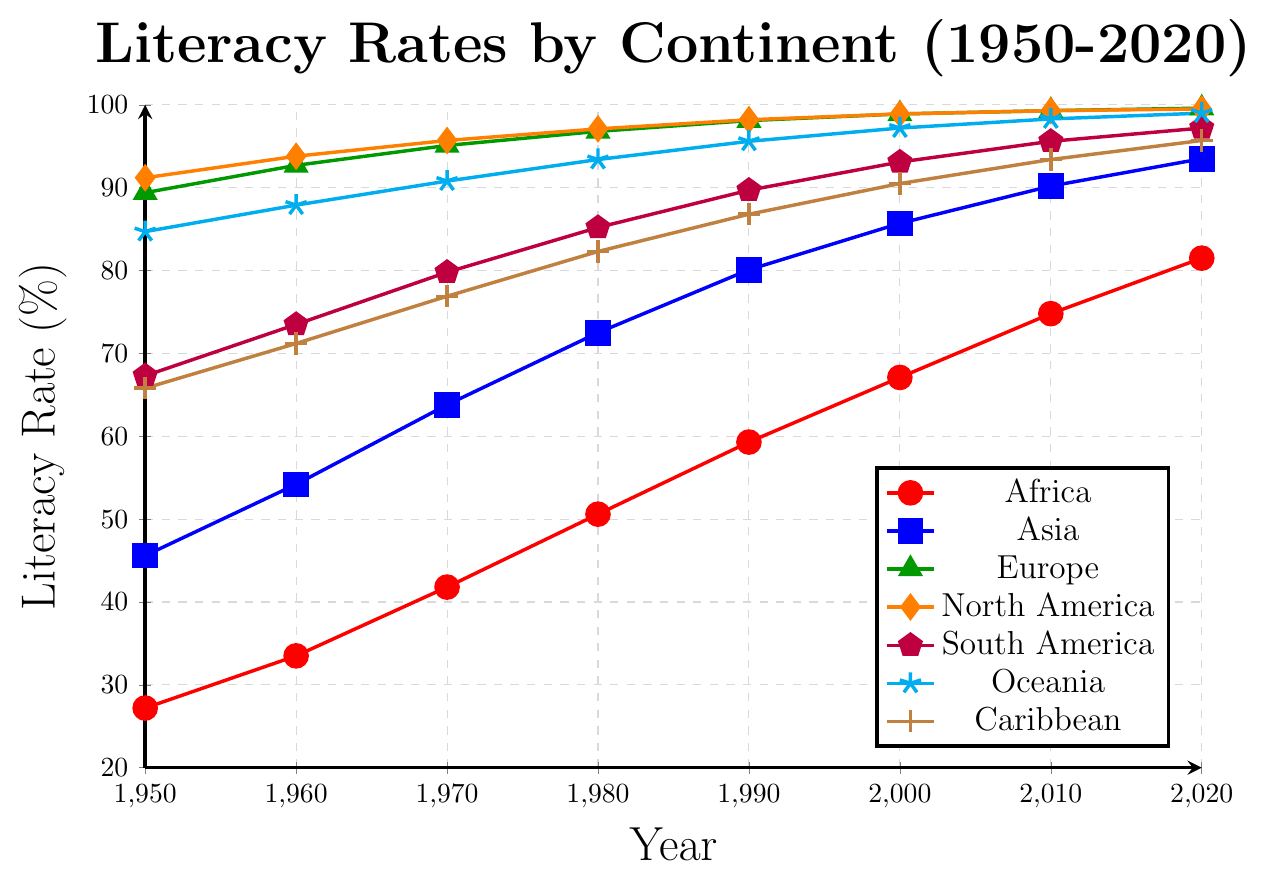Which continent had the lowest literacy rate in 1950? By visually inspecting the figure, the red line representing Africa starts at the lowest point in 1950 compared to the other continents.
Answer: Africa How did the literacy rate in Africa change from 1950 to 2020? Referring to the path of the red line, the literacy rate in Africa increased from 27.2% in 1950 to 81.5% in 2020.
Answer: It increased from 27.2% to 81.5% Which continent had the highest literacy rate in the year 2000? By observing the figure, Europe, represented by the green line, had the highest literacy rate in 2000 at 98.9%.
Answer: Europe Compare the literacy rates of South America and Asia in 1980. Which was higher and by how much? In 1980, South America's literacy rate (purple line) was 85.2%, and Asia's literacy rate (blue line) was 72.5%. The difference is 85.2% - 72.5% = 12.7%.
Answer: South America by 12.7% How many continents had at least a 90% literacy rate by 2020? From the figure, the continents with literacy rates of 90% or higher in 2020 are Europe, North America, South America, Asia, Oceania, and the Caribbean. That's 6 continents.
Answer: Six continents What is the average literacy rate of Oceania from 1950 to 2020? The literacy rates of Oceania (cyan line) for the years are 84.7, 87.9, 90.8, 93.4, 95.6, 97.2, 98.3, and 99.0. Sum these values (84.7 + 87.9 + 90.8 + 93.4 + 95.6 + 97.2 + 98.3 + 99.0) = 747.9 and divide by 8. 747.9 / 8 = 93.49.
Answer: 93.49% Which continent experienced the greatest increase in literacy rate between 1950 and 2020? By calculating the increase for each continent: Africa (81.5 - 27.2 = 54.3), Asia (93.5 - 45.6 = 47.9), Europe (99.6 - 89.4 = 10.2), North America (99.5 - 91.2 = 8.3), South America (97.2 - 67.3 = 29.9), Oceania (99.0 - 84.7 = 14.3), Caribbean (95.7 - 65.8 = 29.9). Africa had the greatest increase at 54.3.
Answer: Africa What is the median literacy rate for Caribbean from 1950 to 2020? The literacy rates of the Caribbean (brown line) are 65.8, 71.2, 76.9, 82.3, 86.8, 90.5, 93.4, and 95.7. Arranging them: 65.8, 71.2, 76.9, 82.3, 86.8, 90.5, 93.4, 95.7. The middle values are 82.3 and 86.8, so the median is (82.3 + 86.8)/2 = 84.55.
Answer: 84.55 